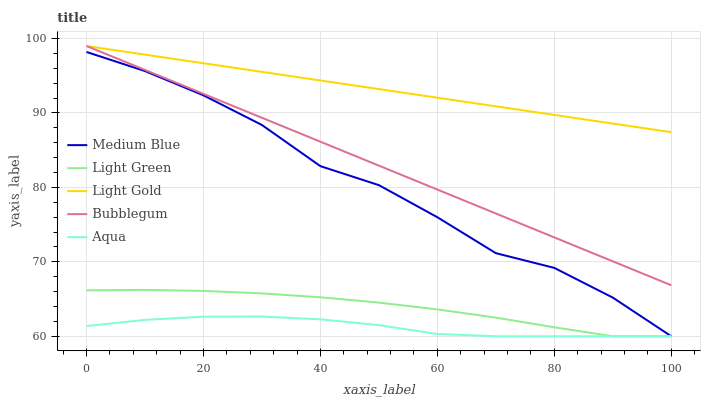Does Aqua have the minimum area under the curve?
Answer yes or no. Yes. Does Light Gold have the maximum area under the curve?
Answer yes or no. Yes. Does Medium Blue have the minimum area under the curve?
Answer yes or no. No. Does Medium Blue have the maximum area under the curve?
Answer yes or no. No. Is Bubblegum the smoothest?
Answer yes or no. Yes. Is Medium Blue the roughest?
Answer yes or no. Yes. Is Light Gold the smoothest?
Answer yes or no. No. Is Light Gold the roughest?
Answer yes or no. No. Does Aqua have the lowest value?
Answer yes or no. Yes. Does Light Gold have the lowest value?
Answer yes or no. No. Does Bubblegum have the highest value?
Answer yes or no. Yes. Does Medium Blue have the highest value?
Answer yes or no. No. Is Aqua less than Bubblegum?
Answer yes or no. Yes. Is Bubblegum greater than Aqua?
Answer yes or no. Yes. Does Aqua intersect Light Green?
Answer yes or no. Yes. Is Aqua less than Light Green?
Answer yes or no. No. Is Aqua greater than Light Green?
Answer yes or no. No. Does Aqua intersect Bubblegum?
Answer yes or no. No. 